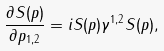<formula> <loc_0><loc_0><loc_500><loc_500>\frac { \partial S ( p ) } { \partial p _ { 1 , 2 } } = i S ( p ) \gamma ^ { 1 , 2 } S ( p ) ,</formula> 